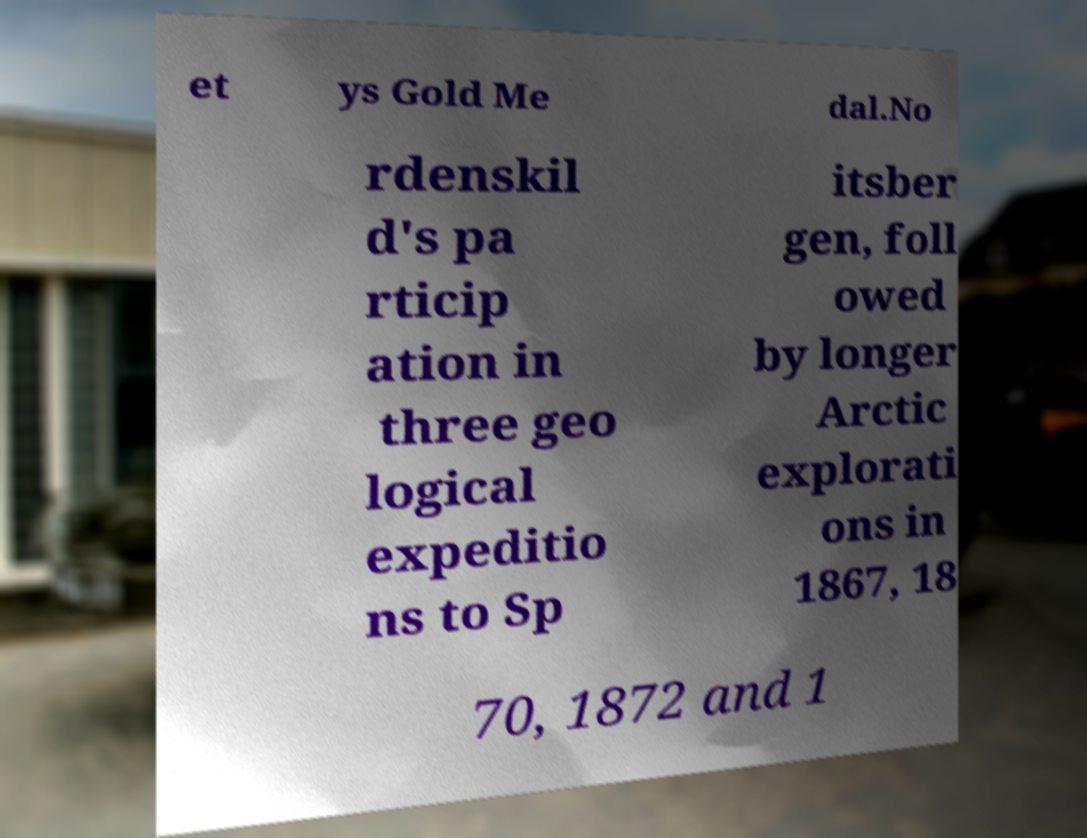Please identify and transcribe the text found in this image. et ys Gold Me dal.No rdenskil d's pa rticip ation in three geo logical expeditio ns to Sp itsber gen, foll owed by longer Arctic explorati ons in 1867, 18 70, 1872 and 1 